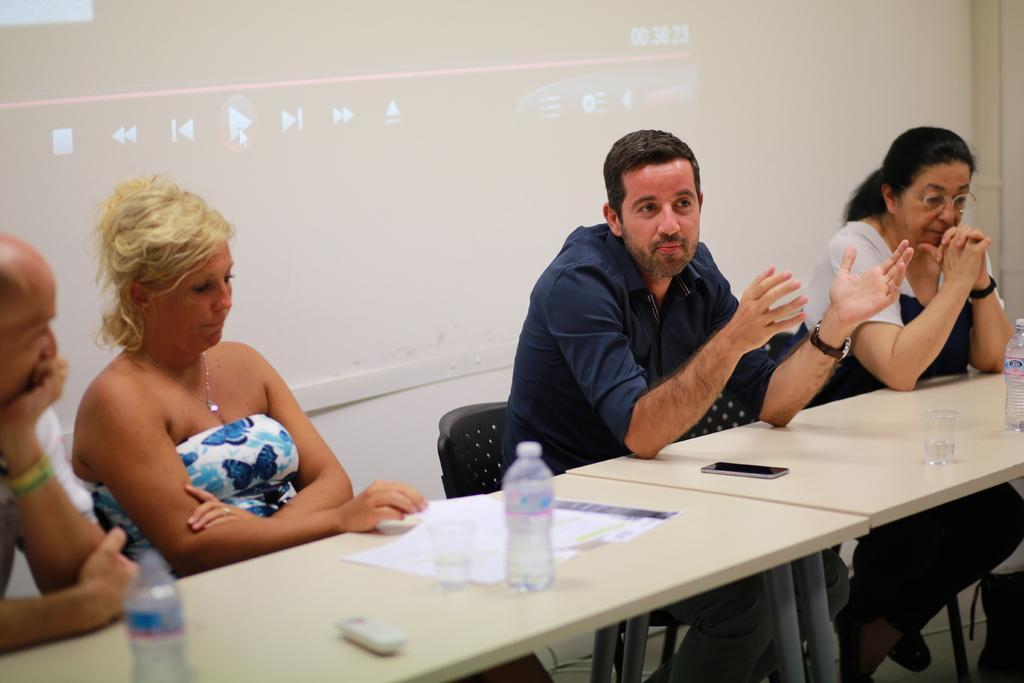In one or two sentences, can you explain what this image depicts? In this image In the middle there is a table on that there is mobile, glass, bottle, remote and papers. On the right there is a woman her hair is short she is sitting. In the middle there is a man he wears blue t shirt and trouser. On the left there are two people sitting. In the background there is a screen and wall. 